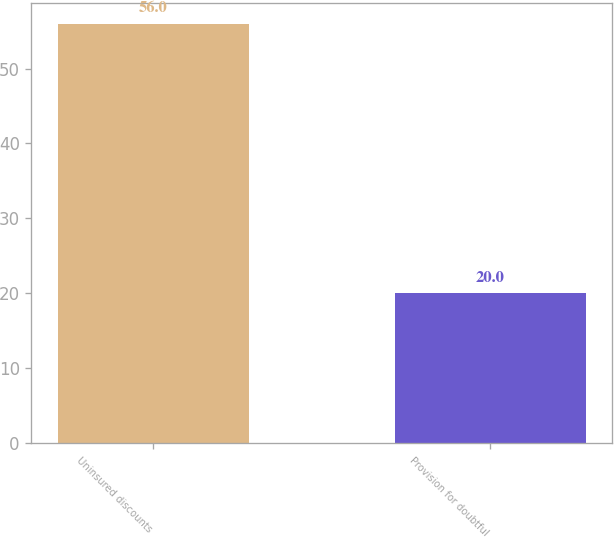Convert chart to OTSL. <chart><loc_0><loc_0><loc_500><loc_500><bar_chart><fcel>Uninsured discounts<fcel>Provision for doubtful<nl><fcel>56<fcel>20<nl></chart> 